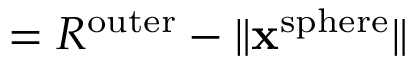<formula> <loc_0><loc_0><loc_500><loc_500>= R ^ { o u t e r } - \| x ^ { s p h e r e } \|</formula> 